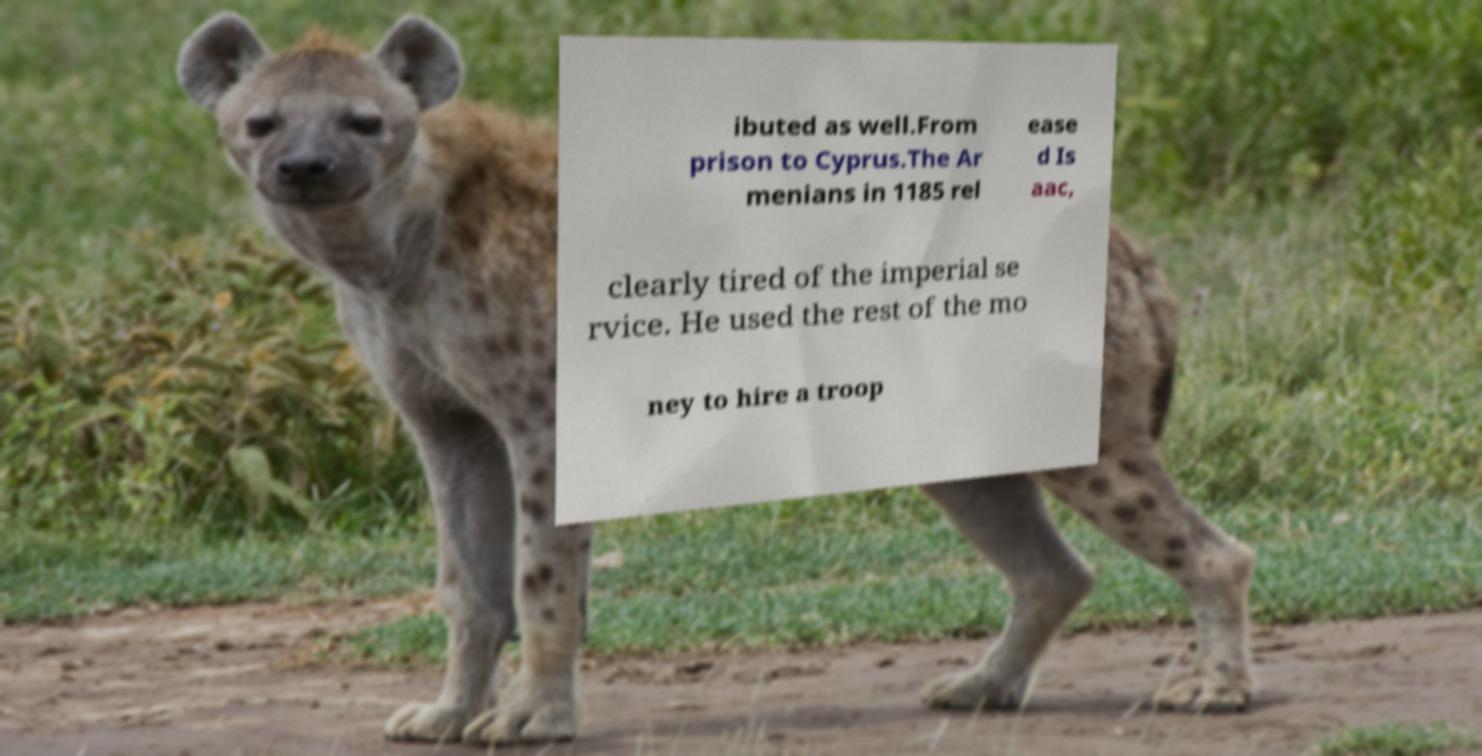Can you accurately transcribe the text from the provided image for me? ibuted as well.From prison to Cyprus.The Ar menians in 1185 rel ease d Is aac, clearly tired of the imperial se rvice. He used the rest of the mo ney to hire a troop 